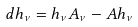<formula> <loc_0><loc_0><loc_500><loc_500>d h _ { \nu } = h _ { \nu } A _ { \nu } - A h _ { \nu }</formula> 